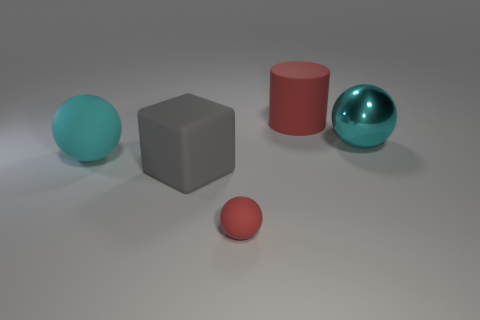Subtract all cyan cubes. Subtract all gray cylinders. How many cubes are left? 1 Subtract all brown cylinders. How many purple spheres are left? 0 Add 2 yellows. How many things exist? 0 Subtract all big blocks. Subtract all small blue metal cylinders. How many objects are left? 4 Add 4 small red spheres. How many small red spheres are left? 5 Add 2 tiny green matte things. How many tiny green matte things exist? 2 Add 2 large cubes. How many objects exist? 7 Subtract all red balls. How many balls are left? 2 Subtract all large cyan balls. How many balls are left? 1 Subtract 0 cyan blocks. How many objects are left? 5 